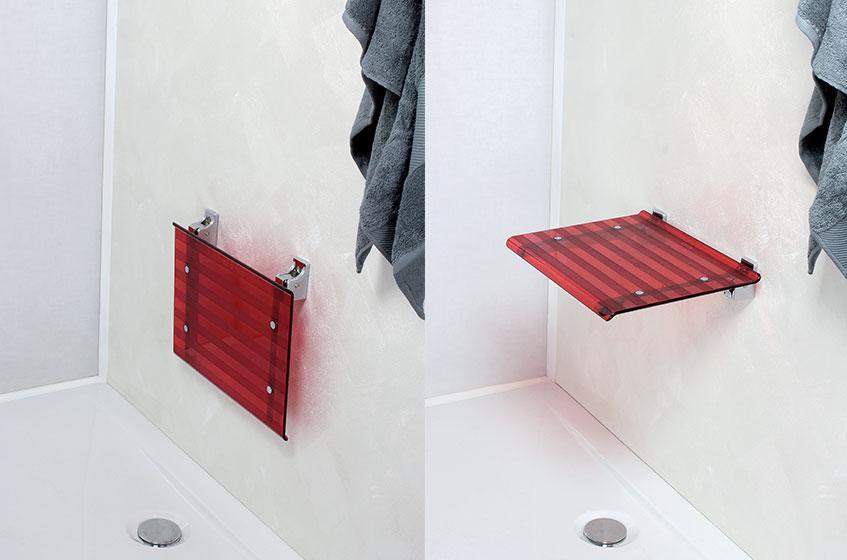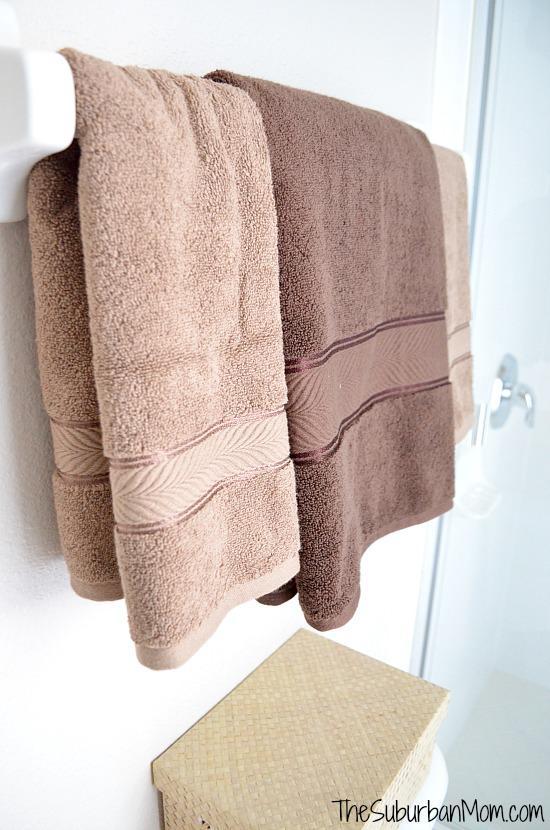The first image is the image on the left, the second image is the image on the right. Given the left and right images, does the statement "A wall mounted bathroom sink is in one image." hold true? Answer yes or no. No. 